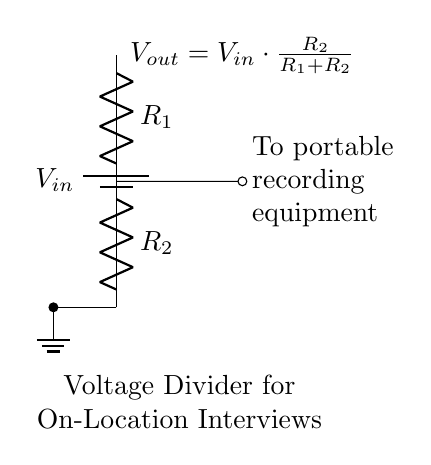What type of circuit is shown? The circuit is a voltage divider, consisting of two resistors in series that divide the input voltage.
Answer: Voltage divider What does R1 represent in this circuit? R1 is one of the two resistors in the voltage divider; it determines how much of the input voltage is dropped across it compared to R2.
Answer: Resistor 1 What is the formula for Vout in this circuit? The voltage output, Vout, is calculated using the formula Vout equals Vin multiplied by the ratio of R2 over the sum of R1 and R2.
Answer: Vout equals Vin times R2 over R1 plus R2 What is the role of the battery in this circuit? The battery provides the input voltage (Vin) that is divided across the resistors R1 and R2, supplying power to the connected equipment.
Answer: Power supply How is Vout connected to the recording equipment? Vout is connected to the portable recording equipment as indicated by the output line leading to it in the circuit diagram.
Answer: Directly to recording equipment If R1 is twice the value of R2, how does this affect Vout? With R1 being twice the value of R2, Vout will be a third of Vin, which means that more voltage is dropped across R1 than R2. This happens because the ratio in the formula favors the larger resistor.
Answer: Vout is one-third of Vin What is the significance of having a voltage divider for portable equipment? A voltage divider allows the adjustment of the voltage supplied to the portable recording equipment, ensuring it operates within its required voltage range, thus preventing damage and ensuring functionality.
Answer: Voltage regulation 